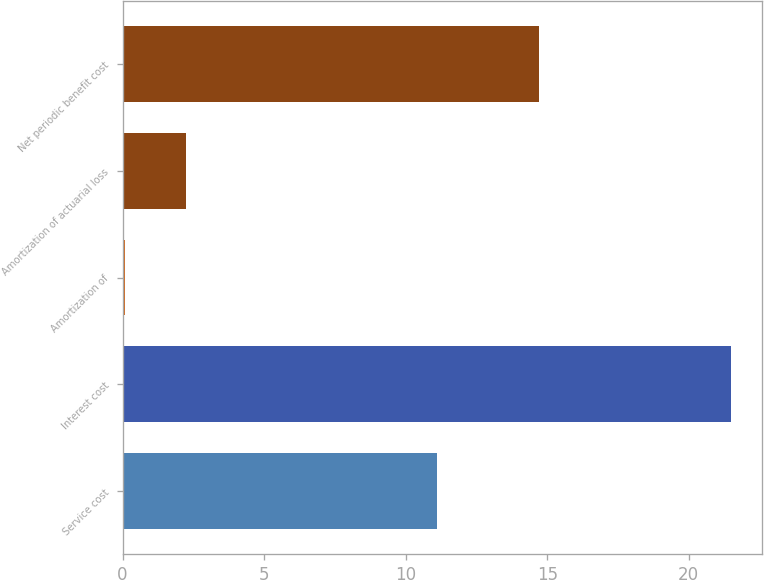<chart> <loc_0><loc_0><loc_500><loc_500><bar_chart><fcel>Service cost<fcel>Interest cost<fcel>Amortization of<fcel>Amortization of actuarial loss<fcel>Net periodic benefit cost<nl><fcel>11.1<fcel>21.5<fcel>0.1<fcel>2.24<fcel>14.7<nl></chart> 